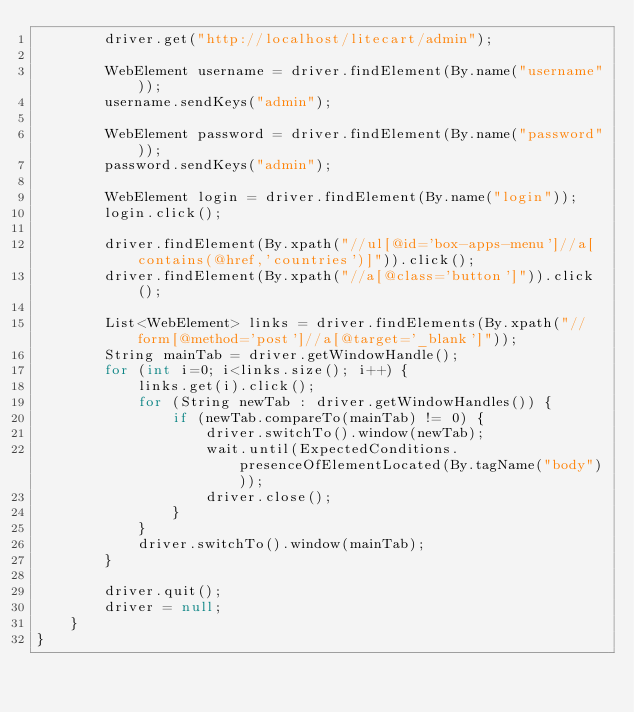Convert code to text. <code><loc_0><loc_0><loc_500><loc_500><_Java_>		driver.get("http://localhost/litecart/admin");
		
		WebElement username = driver.findElement(By.name("username"));
		username.sendKeys("admin");
		
		WebElement password = driver.findElement(By.name("password"));
		password.sendKeys("admin");	
		
		WebElement login = driver.findElement(By.name("login"));
		login.click();
		
		driver.findElement(By.xpath("//ul[@id='box-apps-menu']//a[contains(@href,'countries')]")).click();
		driver.findElement(By.xpath("//a[@class='button']")).click();
		
		List<WebElement> links = driver.findElements(By.xpath("//form[@method='post']//a[@target='_blank']"));
		String mainTab = driver.getWindowHandle();
		for (int i=0; i<links.size(); i++) {
			links.get(i).click();
			for (String newTab : driver.getWindowHandles()) {
				if (newTab.compareTo(mainTab) != 0) {
					driver.switchTo().window(newTab);
					wait.until(ExpectedConditions.presenceOfElementLocated(By.tagName("body")));
					driver.close();
				}
			}
			driver.switchTo().window(mainTab);
		}
		
		driver.quit();
		driver = null;
	}
}
</code> 